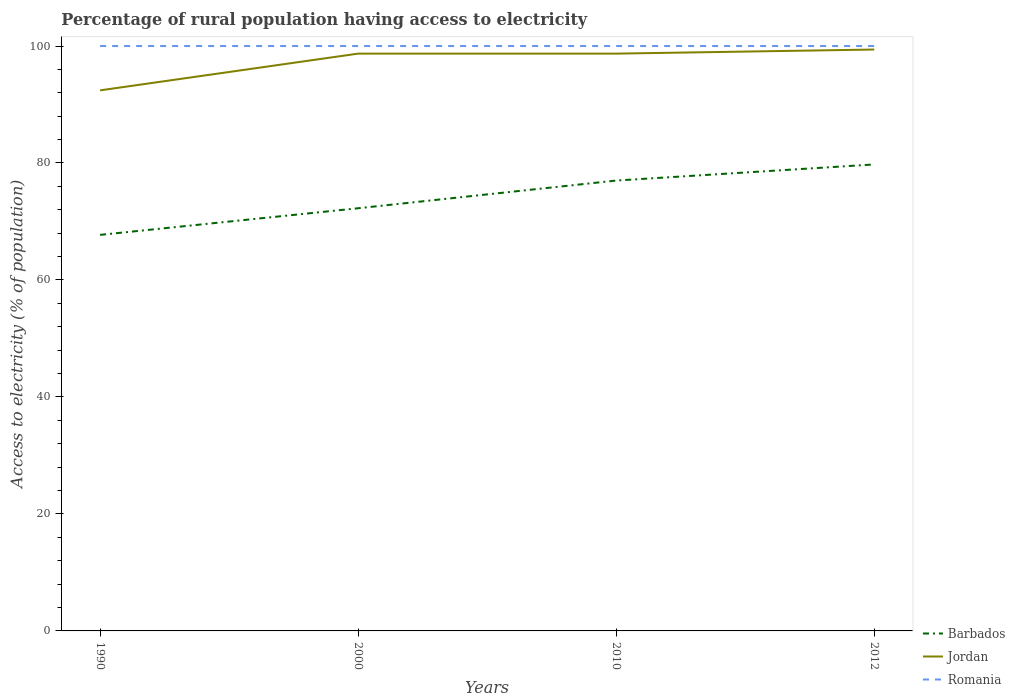How many different coloured lines are there?
Your answer should be very brief. 3. Is the number of lines equal to the number of legend labels?
Offer a very short reply. Yes. Across all years, what is the maximum percentage of rural population having access to electricity in Romania?
Your answer should be very brief. 100. What is the total percentage of rural population having access to electricity in Jordan in the graph?
Give a very brief answer. -0.7. How many lines are there?
Provide a succinct answer. 3. What is the difference between two consecutive major ticks on the Y-axis?
Your answer should be compact. 20. Are the values on the major ticks of Y-axis written in scientific E-notation?
Make the answer very short. No. Does the graph contain any zero values?
Provide a succinct answer. No. Does the graph contain grids?
Your answer should be very brief. No. How many legend labels are there?
Provide a succinct answer. 3. How are the legend labels stacked?
Ensure brevity in your answer.  Vertical. What is the title of the graph?
Provide a succinct answer. Percentage of rural population having access to electricity. What is the label or title of the Y-axis?
Offer a very short reply. Access to electricity (% of population). What is the Access to electricity (% of population) of Barbados in 1990?
Offer a very short reply. 67.71. What is the Access to electricity (% of population) of Jordan in 1990?
Your answer should be compact. 92.42. What is the Access to electricity (% of population) in Romania in 1990?
Provide a short and direct response. 100. What is the Access to electricity (% of population) in Barbados in 2000?
Offer a very short reply. 72.27. What is the Access to electricity (% of population) in Jordan in 2000?
Offer a terse response. 98.7. What is the Access to electricity (% of population) of Romania in 2000?
Keep it short and to the point. 100. What is the Access to electricity (% of population) of Jordan in 2010?
Provide a succinct answer. 98.7. What is the Access to electricity (% of population) in Romania in 2010?
Your answer should be compact. 100. What is the Access to electricity (% of population) of Barbados in 2012?
Your answer should be compact. 79.75. What is the Access to electricity (% of population) of Jordan in 2012?
Provide a short and direct response. 99.4. Across all years, what is the maximum Access to electricity (% of population) of Barbados?
Keep it short and to the point. 79.75. Across all years, what is the maximum Access to electricity (% of population) in Jordan?
Keep it short and to the point. 99.4. Across all years, what is the minimum Access to electricity (% of population) in Barbados?
Your answer should be very brief. 67.71. Across all years, what is the minimum Access to electricity (% of population) in Jordan?
Offer a terse response. 92.42. What is the total Access to electricity (% of population) of Barbados in the graph?
Your answer should be compact. 296.73. What is the total Access to electricity (% of population) in Jordan in the graph?
Provide a short and direct response. 389.22. What is the difference between the Access to electricity (% of population) of Barbados in 1990 and that in 2000?
Provide a short and direct response. -4.55. What is the difference between the Access to electricity (% of population) of Jordan in 1990 and that in 2000?
Your response must be concise. -6.28. What is the difference between the Access to electricity (% of population) of Romania in 1990 and that in 2000?
Offer a terse response. 0. What is the difference between the Access to electricity (% of population) of Barbados in 1990 and that in 2010?
Make the answer very short. -9.29. What is the difference between the Access to electricity (% of population) in Jordan in 1990 and that in 2010?
Offer a terse response. -6.28. What is the difference between the Access to electricity (% of population) of Romania in 1990 and that in 2010?
Give a very brief answer. 0. What is the difference between the Access to electricity (% of population) of Barbados in 1990 and that in 2012?
Your answer should be very brief. -12.04. What is the difference between the Access to electricity (% of population) in Jordan in 1990 and that in 2012?
Provide a succinct answer. -6.98. What is the difference between the Access to electricity (% of population) in Romania in 1990 and that in 2012?
Keep it short and to the point. 0. What is the difference between the Access to electricity (% of population) in Barbados in 2000 and that in 2010?
Your answer should be very brief. -4.74. What is the difference between the Access to electricity (% of population) in Jordan in 2000 and that in 2010?
Your response must be concise. 0. What is the difference between the Access to electricity (% of population) in Romania in 2000 and that in 2010?
Ensure brevity in your answer.  0. What is the difference between the Access to electricity (% of population) in Barbados in 2000 and that in 2012?
Offer a terse response. -7.49. What is the difference between the Access to electricity (% of population) of Barbados in 2010 and that in 2012?
Provide a short and direct response. -2.75. What is the difference between the Access to electricity (% of population) in Barbados in 1990 and the Access to electricity (% of population) in Jordan in 2000?
Your response must be concise. -30.99. What is the difference between the Access to electricity (% of population) in Barbados in 1990 and the Access to electricity (% of population) in Romania in 2000?
Your response must be concise. -32.29. What is the difference between the Access to electricity (% of population) in Jordan in 1990 and the Access to electricity (% of population) in Romania in 2000?
Your answer should be very brief. -7.58. What is the difference between the Access to electricity (% of population) in Barbados in 1990 and the Access to electricity (% of population) in Jordan in 2010?
Ensure brevity in your answer.  -30.99. What is the difference between the Access to electricity (% of population) of Barbados in 1990 and the Access to electricity (% of population) of Romania in 2010?
Ensure brevity in your answer.  -32.29. What is the difference between the Access to electricity (% of population) in Jordan in 1990 and the Access to electricity (% of population) in Romania in 2010?
Offer a very short reply. -7.58. What is the difference between the Access to electricity (% of population) in Barbados in 1990 and the Access to electricity (% of population) in Jordan in 2012?
Provide a succinct answer. -31.69. What is the difference between the Access to electricity (% of population) in Barbados in 1990 and the Access to electricity (% of population) in Romania in 2012?
Provide a succinct answer. -32.29. What is the difference between the Access to electricity (% of population) in Jordan in 1990 and the Access to electricity (% of population) in Romania in 2012?
Your answer should be very brief. -7.58. What is the difference between the Access to electricity (% of population) in Barbados in 2000 and the Access to electricity (% of population) in Jordan in 2010?
Offer a very short reply. -26.43. What is the difference between the Access to electricity (% of population) in Barbados in 2000 and the Access to electricity (% of population) in Romania in 2010?
Give a very brief answer. -27.73. What is the difference between the Access to electricity (% of population) of Jordan in 2000 and the Access to electricity (% of population) of Romania in 2010?
Provide a succinct answer. -1.3. What is the difference between the Access to electricity (% of population) in Barbados in 2000 and the Access to electricity (% of population) in Jordan in 2012?
Make the answer very short. -27.14. What is the difference between the Access to electricity (% of population) in Barbados in 2000 and the Access to electricity (% of population) in Romania in 2012?
Your answer should be very brief. -27.73. What is the difference between the Access to electricity (% of population) in Barbados in 2010 and the Access to electricity (% of population) in Jordan in 2012?
Keep it short and to the point. -22.4. What is the difference between the Access to electricity (% of population) in Barbados in 2010 and the Access to electricity (% of population) in Romania in 2012?
Keep it short and to the point. -23. What is the average Access to electricity (% of population) of Barbados per year?
Provide a short and direct response. 74.18. What is the average Access to electricity (% of population) of Jordan per year?
Your answer should be compact. 97.3. What is the average Access to electricity (% of population) in Romania per year?
Offer a terse response. 100. In the year 1990, what is the difference between the Access to electricity (% of population) in Barbados and Access to electricity (% of population) in Jordan?
Your answer should be very brief. -24.71. In the year 1990, what is the difference between the Access to electricity (% of population) of Barbados and Access to electricity (% of population) of Romania?
Your answer should be very brief. -32.29. In the year 1990, what is the difference between the Access to electricity (% of population) in Jordan and Access to electricity (% of population) in Romania?
Your answer should be very brief. -7.58. In the year 2000, what is the difference between the Access to electricity (% of population) in Barbados and Access to electricity (% of population) in Jordan?
Your response must be concise. -26.43. In the year 2000, what is the difference between the Access to electricity (% of population) of Barbados and Access to electricity (% of population) of Romania?
Ensure brevity in your answer.  -27.73. In the year 2000, what is the difference between the Access to electricity (% of population) in Jordan and Access to electricity (% of population) in Romania?
Ensure brevity in your answer.  -1.3. In the year 2010, what is the difference between the Access to electricity (% of population) of Barbados and Access to electricity (% of population) of Jordan?
Offer a terse response. -21.7. In the year 2010, what is the difference between the Access to electricity (% of population) in Jordan and Access to electricity (% of population) in Romania?
Give a very brief answer. -1.3. In the year 2012, what is the difference between the Access to electricity (% of population) in Barbados and Access to electricity (% of population) in Jordan?
Provide a short and direct response. -19.65. In the year 2012, what is the difference between the Access to electricity (% of population) of Barbados and Access to electricity (% of population) of Romania?
Ensure brevity in your answer.  -20.25. In the year 2012, what is the difference between the Access to electricity (% of population) in Jordan and Access to electricity (% of population) in Romania?
Provide a short and direct response. -0.6. What is the ratio of the Access to electricity (% of population) of Barbados in 1990 to that in 2000?
Ensure brevity in your answer.  0.94. What is the ratio of the Access to electricity (% of population) in Jordan in 1990 to that in 2000?
Ensure brevity in your answer.  0.94. What is the ratio of the Access to electricity (% of population) of Romania in 1990 to that in 2000?
Offer a very short reply. 1. What is the ratio of the Access to electricity (% of population) in Barbados in 1990 to that in 2010?
Your response must be concise. 0.88. What is the ratio of the Access to electricity (% of population) of Jordan in 1990 to that in 2010?
Make the answer very short. 0.94. What is the ratio of the Access to electricity (% of population) in Romania in 1990 to that in 2010?
Your answer should be compact. 1. What is the ratio of the Access to electricity (% of population) in Barbados in 1990 to that in 2012?
Keep it short and to the point. 0.85. What is the ratio of the Access to electricity (% of population) of Jordan in 1990 to that in 2012?
Your answer should be very brief. 0.93. What is the ratio of the Access to electricity (% of population) of Romania in 1990 to that in 2012?
Your answer should be very brief. 1. What is the ratio of the Access to electricity (% of population) in Barbados in 2000 to that in 2010?
Offer a very short reply. 0.94. What is the ratio of the Access to electricity (% of population) in Jordan in 2000 to that in 2010?
Your answer should be compact. 1. What is the ratio of the Access to electricity (% of population) of Barbados in 2000 to that in 2012?
Make the answer very short. 0.91. What is the ratio of the Access to electricity (% of population) in Romania in 2000 to that in 2012?
Your response must be concise. 1. What is the ratio of the Access to electricity (% of population) of Barbados in 2010 to that in 2012?
Offer a terse response. 0.97. What is the ratio of the Access to electricity (% of population) in Romania in 2010 to that in 2012?
Your response must be concise. 1. What is the difference between the highest and the second highest Access to electricity (% of population) in Barbados?
Your answer should be very brief. 2.75. What is the difference between the highest and the second highest Access to electricity (% of population) of Jordan?
Give a very brief answer. 0.7. What is the difference between the highest and the second highest Access to electricity (% of population) of Romania?
Give a very brief answer. 0. What is the difference between the highest and the lowest Access to electricity (% of population) of Barbados?
Your answer should be compact. 12.04. What is the difference between the highest and the lowest Access to electricity (% of population) in Jordan?
Offer a terse response. 6.98. 